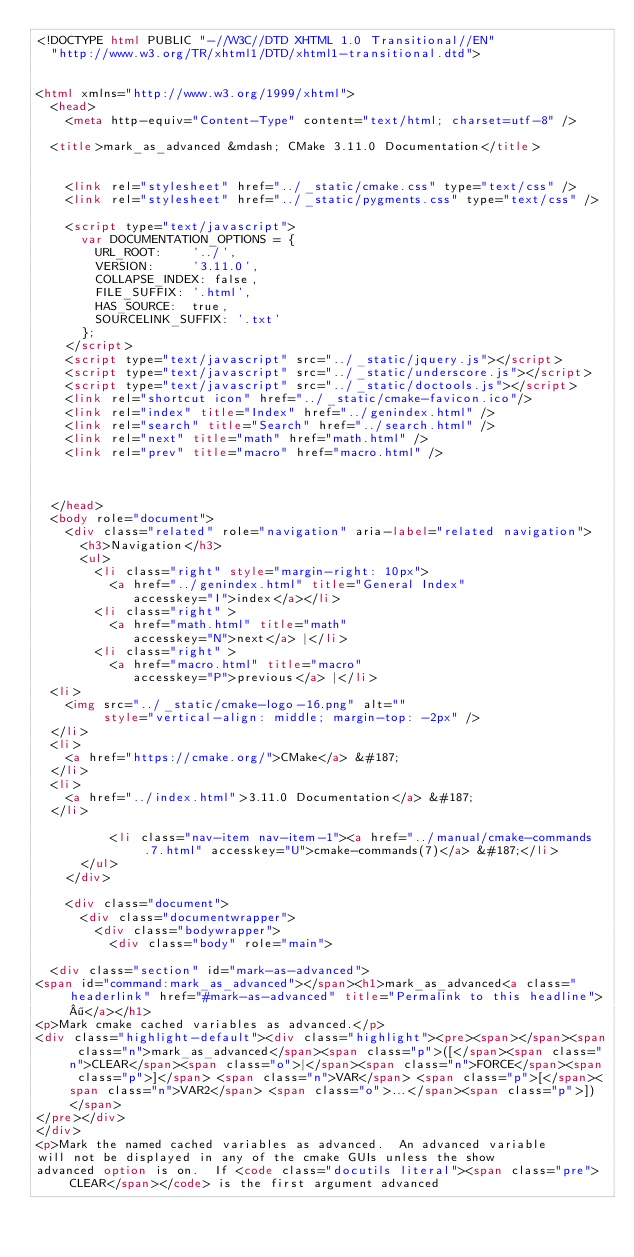Convert code to text. <code><loc_0><loc_0><loc_500><loc_500><_HTML_><!DOCTYPE html PUBLIC "-//W3C//DTD XHTML 1.0 Transitional//EN"
  "http://www.w3.org/TR/xhtml1/DTD/xhtml1-transitional.dtd">


<html xmlns="http://www.w3.org/1999/xhtml">
  <head>
    <meta http-equiv="Content-Type" content="text/html; charset=utf-8" />
    
  <title>mark_as_advanced &mdash; CMake 3.11.0 Documentation</title>

    
    <link rel="stylesheet" href="../_static/cmake.css" type="text/css" />
    <link rel="stylesheet" href="../_static/pygments.css" type="text/css" />
    
    <script type="text/javascript">
      var DOCUMENTATION_OPTIONS = {
        URL_ROOT:    '../',
        VERSION:     '3.11.0',
        COLLAPSE_INDEX: false,
        FILE_SUFFIX: '.html',
        HAS_SOURCE:  true,
        SOURCELINK_SUFFIX: '.txt'
      };
    </script>
    <script type="text/javascript" src="../_static/jquery.js"></script>
    <script type="text/javascript" src="../_static/underscore.js"></script>
    <script type="text/javascript" src="../_static/doctools.js"></script>
    <link rel="shortcut icon" href="../_static/cmake-favicon.ico"/>
    <link rel="index" title="Index" href="../genindex.html" />
    <link rel="search" title="Search" href="../search.html" />
    <link rel="next" title="math" href="math.html" />
    <link rel="prev" title="macro" href="macro.html" />
  
 

  </head>
  <body role="document">
    <div class="related" role="navigation" aria-label="related navigation">
      <h3>Navigation</h3>
      <ul>
        <li class="right" style="margin-right: 10px">
          <a href="../genindex.html" title="General Index"
             accesskey="I">index</a></li>
        <li class="right" >
          <a href="math.html" title="math"
             accesskey="N">next</a> |</li>
        <li class="right" >
          <a href="macro.html" title="macro"
             accesskey="P">previous</a> |</li>
  <li>
    <img src="../_static/cmake-logo-16.png" alt=""
         style="vertical-align: middle; margin-top: -2px" />
  </li>
  <li>
    <a href="https://cmake.org/">CMake</a> &#187;
  </li>
  <li>
    <a href="../index.html">3.11.0 Documentation</a> &#187;
  </li>

          <li class="nav-item nav-item-1"><a href="../manual/cmake-commands.7.html" accesskey="U">cmake-commands(7)</a> &#187;</li> 
      </ul>
    </div>  

    <div class="document">
      <div class="documentwrapper">
        <div class="bodywrapper">
          <div class="body" role="main">
            
  <div class="section" id="mark-as-advanced">
<span id="command:mark_as_advanced"></span><h1>mark_as_advanced<a class="headerlink" href="#mark-as-advanced" title="Permalink to this headline">¶</a></h1>
<p>Mark cmake cached variables as advanced.</p>
<div class="highlight-default"><div class="highlight"><pre><span></span><span class="n">mark_as_advanced</span><span class="p">([</span><span class="n">CLEAR</span><span class="o">|</span><span class="n">FORCE</span><span class="p">]</span> <span class="n">VAR</span> <span class="p">[</span><span class="n">VAR2</span> <span class="o">...</span><span class="p">])</span>
</pre></div>
</div>
<p>Mark the named cached variables as advanced.  An advanced variable
will not be displayed in any of the cmake GUIs unless the show
advanced option is on.  If <code class="docutils literal"><span class="pre">CLEAR</span></code> is the first argument advanced</code> 